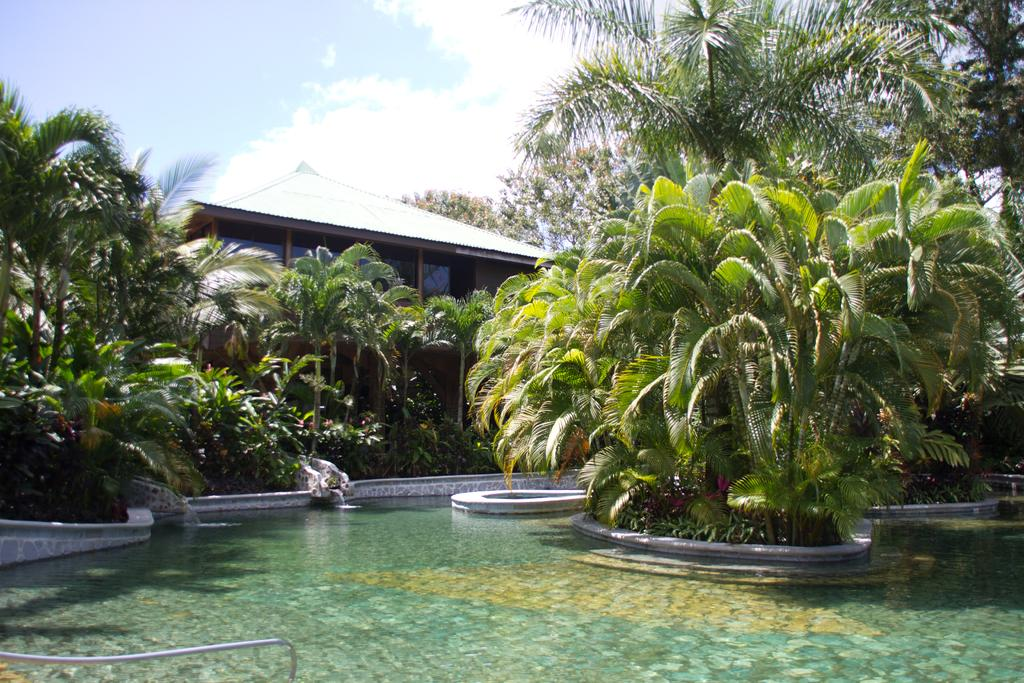What is the primary element present in the image? There is water in the image. What type of vegetation can be seen in the image? There are trees in the image, and they are green in color. What type of structure is visible in the image? There is a building in the image. What can be seen in the background of the image? The sky is visible in the background of the image. Can you see a button on any of the trees in the image? There is no button present on the trees in the image. 